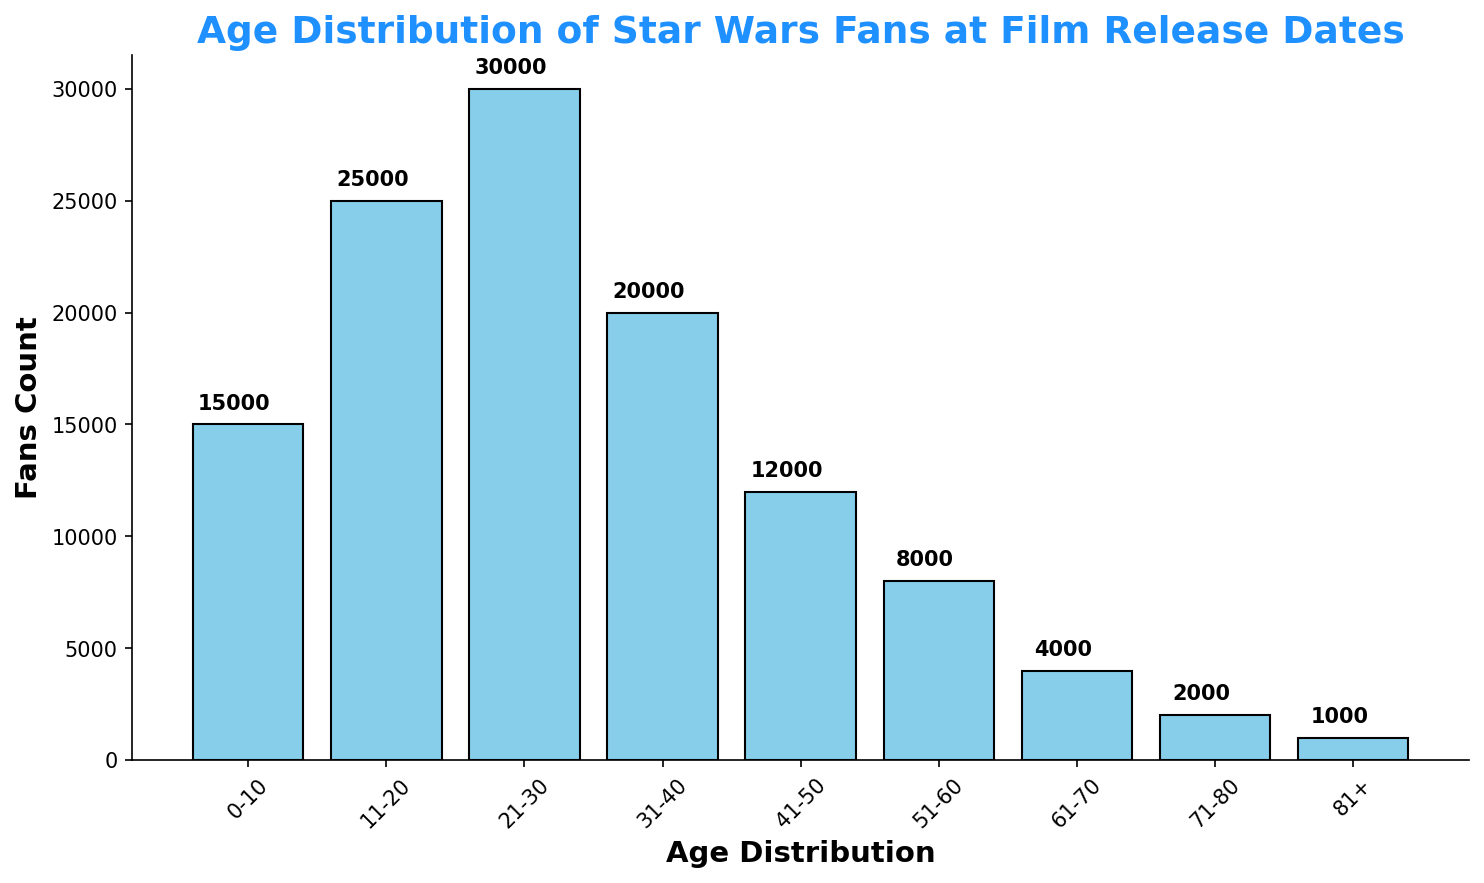what is the age group with the highest number of Star Wars fans? The bar that corresponds to the age group 21-30 has the highest height among all, showing 30,000 fans.
Answer: 21-30 Which age group has the smallest number of fans? The shortest bar is for the age group 81+, which indicates a count of 1,000 fans.
Answer: 81+ What is the combined total of fans in the age groups 0-10 and 11-20? The count for 0-10 is 15,000 and for 11-20 is 25,000. The combined total is 15,000 + 25,000, which equals 40,000.
Answer: 40,000 How many more fans are there in the 31-40 age group compared to the 41-50 age group? The 31-40 age group has 20,000 fans, and the 41-50 age group has 12,000 fans. The difference is 20,000 - 12,000, which is 8,000.
Answer: 8,000 Which age group has twice as many fans as the 51-60 age group? The 51-60 age group has 8,000 fans. The 21-30 age group has 30,000 fans, which is more than twice 8,000. None of the age groups exactly have twice as many fans.
Answer: None How does the number of fans in the 0-10 age group compare to that in the 61-70 age group? The 0-10 age group has 15,000 fans, while the 61-70 age group has 4,000 fans. 15,000 is more than 4,000.
Answer: 0-10 > 61-70 What is the average number of fans across all age groups? Summing the fans count gives 120,000. There are 9 age groups, so the average number of fans is 120,000 / 9, which equals about 13,333.
Answer: 13,333 What is the median number of fans across all age groups? Ordering the counts: 1,000, 2,000, 4,000, 8,000, 12,000, 15,000, 20,000, 25,000, 30,000. The middle value (5th) is 12,000.
Answer: 12,000 Which two consecutive age groups have the smallest difference in fan numbers? Calculate the differences: 
0-10 to 11-20: 10,000, 
11-20 to 21-30: 5,000, 
21-30 to 31-40: 10,000, 
31-40 to 41-50: 8,000, 
41-50 to 51-60: 4,000, 
51-60 to 61-70: 4,000, 
61-70 to 71-80: 2,000, 
71-80 to 81+: 1,000. 
The smallest difference is between 71-80 and 81+ (2,000 - 1,000 = 1,000).
Answer: 71-80 and 81+ 